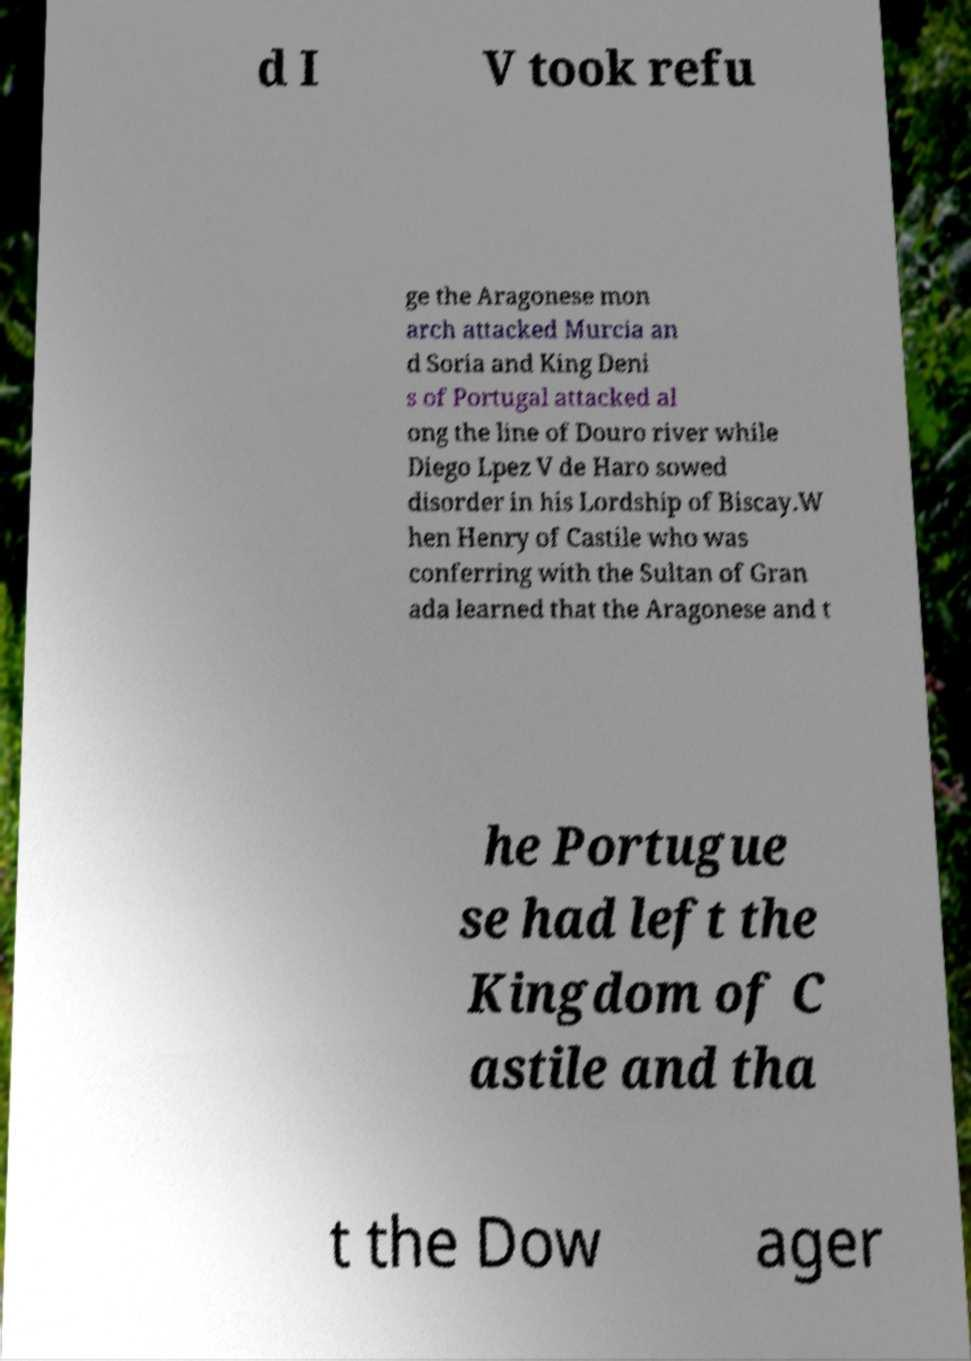Could you extract and type out the text from this image? d I V took refu ge the Aragonese mon arch attacked Murcia an d Soria and King Deni s of Portugal attacked al ong the line of Douro river while Diego Lpez V de Haro sowed disorder in his Lordship of Biscay.W hen Henry of Castile who was conferring with the Sultan of Gran ada learned that the Aragonese and t he Portugue se had left the Kingdom of C astile and tha t the Dow ager 